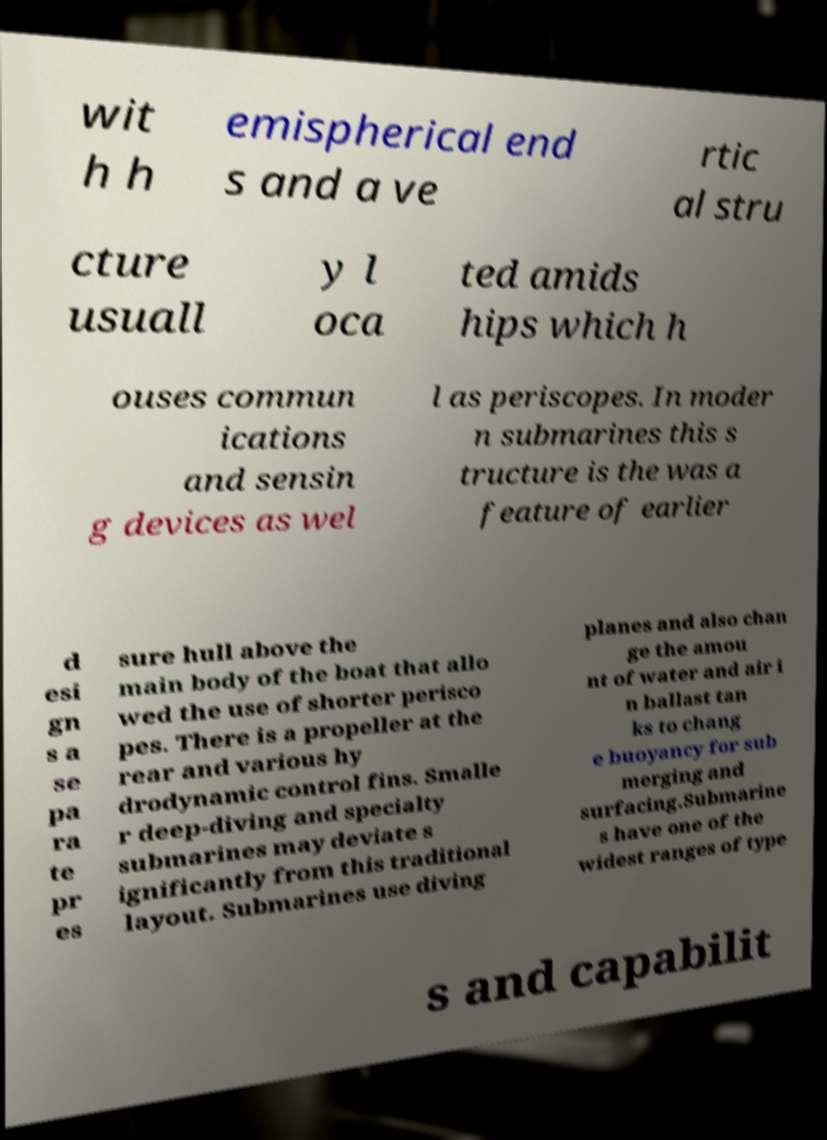Can you read and provide the text displayed in the image?This photo seems to have some interesting text. Can you extract and type it out for me? wit h h emispherical end s and a ve rtic al stru cture usuall y l oca ted amids hips which h ouses commun ications and sensin g devices as wel l as periscopes. In moder n submarines this s tructure is the was a feature of earlier d esi gn s a se pa ra te pr es sure hull above the main body of the boat that allo wed the use of shorter perisco pes. There is a propeller at the rear and various hy drodynamic control fins. Smalle r deep-diving and specialty submarines may deviate s ignificantly from this traditional layout. Submarines use diving planes and also chan ge the amou nt of water and air i n ballast tan ks to chang e buoyancy for sub merging and surfacing.Submarine s have one of the widest ranges of type s and capabilit 